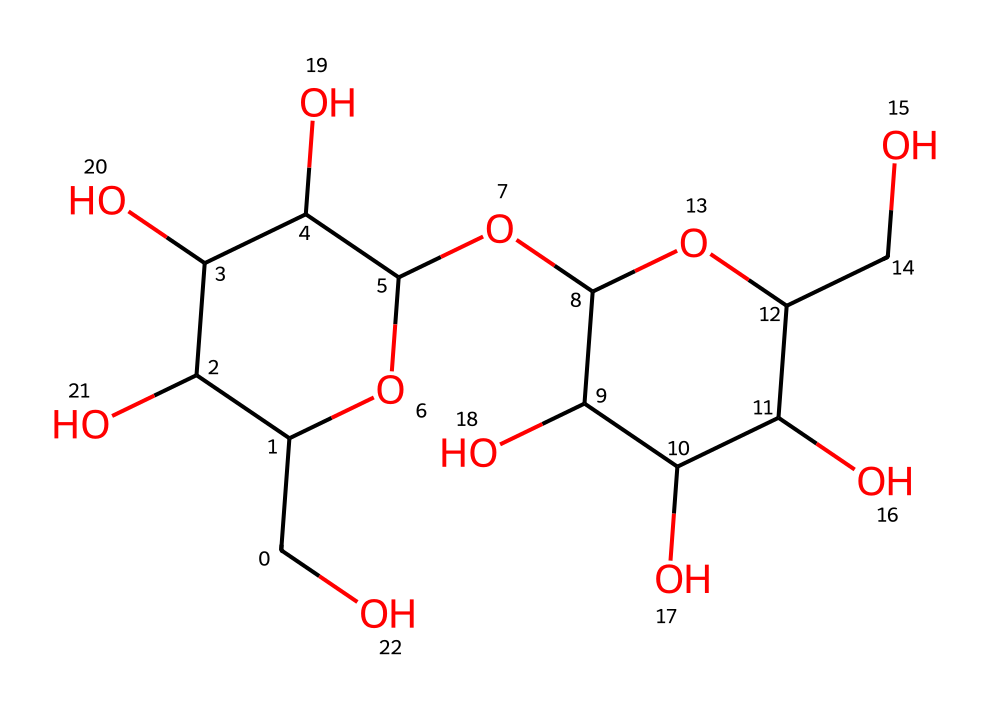What is the main function of maltodextrin in sports gels? Maltodextrin serves as a quick source of energy in sports gels, being a carbohydrate that can be rapidly absorbed by the body during exercise.
Answer: energy source How many oxygen atoms are present in maltodextrin? By analyzing the SMILES representation, we can count a total of eight oxygen atoms in the structure.
Answer: eight What type of carbohydrate is maltodextrin classified as? Maltodextrin is classified as an oligosaccharide because it comprises several monosaccharide units linked together.
Answer: oligosaccharide How many glucose units are in the maltodextrin structure? The chemical structure indicates that maltodextrin contains multiple glucose units, specifically five, based on how the hydroxyl groups and glycosidic bonds are arranged.
Answer: five What is the primary linkage type found in maltodextrin? The structure of maltodextrin shows that it primarily contains alpha-1,4-glycosidic linkages, typical for starch-derived carbohydrates.
Answer: alpha-1,4 What is the molecular formula for maltodextrin based on the SMILES? By decoding the chemical structure from the SMILES notation, the molecular formula can be identified as C18H36O18.
Answer: C18H36O18 What role do the hydroxyl groups play in maltodextrin's function? The hydroxyl groups in maltodextrin facilitate its solubility in water, which is crucial for its rapid absorption in the body during intense physical activity.
Answer: solubility 